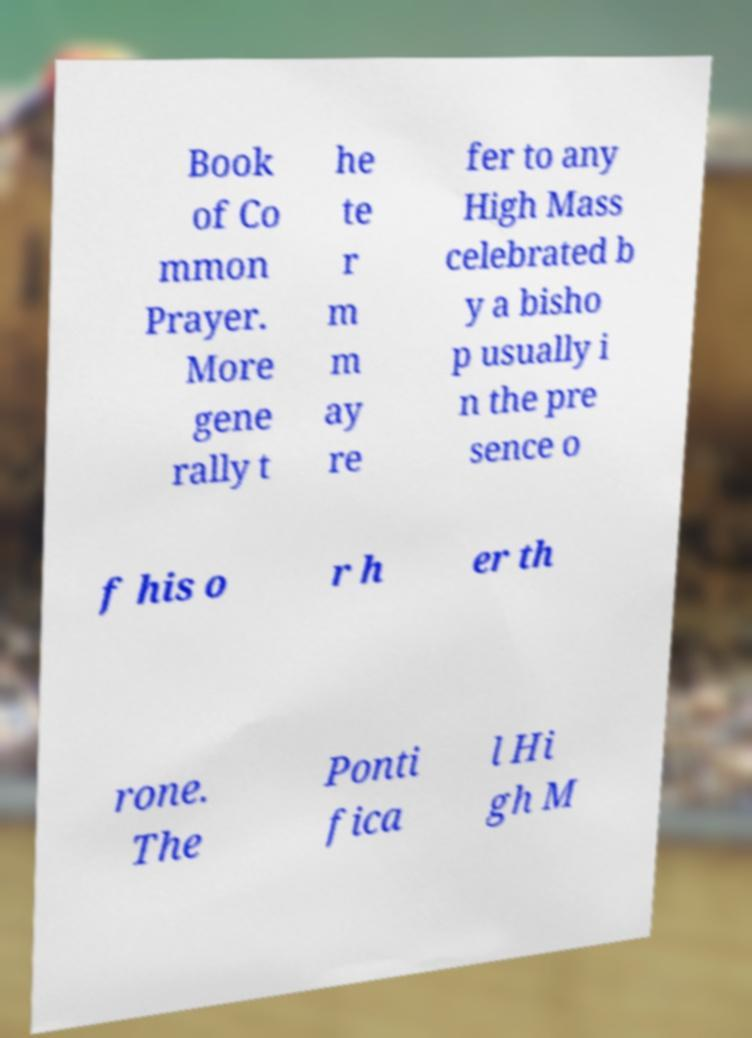Please read and relay the text visible in this image. What does it say? Book of Co mmon Prayer. More gene rally t he te r m m ay re fer to any High Mass celebrated b y a bisho p usually i n the pre sence o f his o r h er th rone. The Ponti fica l Hi gh M 